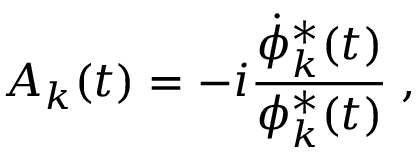Convert formula to latex. <formula><loc_0><loc_0><loc_500><loc_500>A _ { k } ( t ) = - i \frac { \dot { \phi } _ { k } ^ { * } ( t ) } { \phi _ { k } ^ { * } ( t ) } \, ,</formula> 